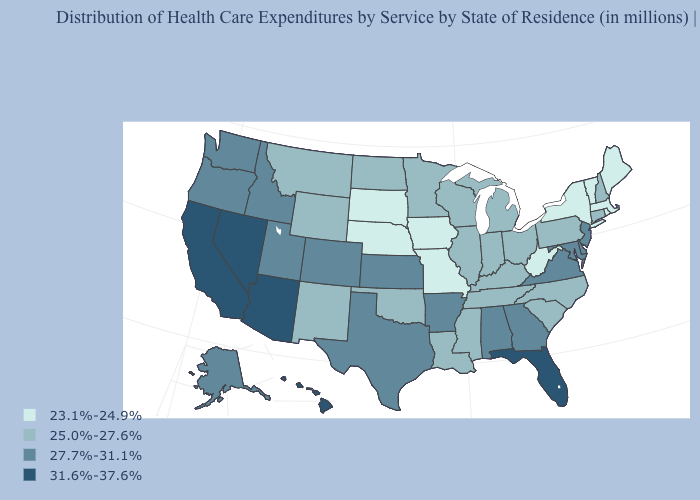Among the states that border Maine , which have the lowest value?
Concise answer only. New Hampshire. Does Nevada have the same value as California?
Answer briefly. Yes. Among the states that border Colorado , does Arizona have the highest value?
Write a very short answer. Yes. Is the legend a continuous bar?
Quick response, please. No. What is the lowest value in the USA?
Keep it brief. 23.1%-24.9%. Does Michigan have the highest value in the USA?
Answer briefly. No. What is the value of South Carolina?
Answer briefly. 25.0%-27.6%. Name the states that have a value in the range 31.6%-37.6%?
Write a very short answer. Arizona, California, Florida, Hawaii, Nevada. What is the value of Arkansas?
Quick response, please. 27.7%-31.1%. Does the map have missing data?
Answer briefly. No. Does Illinois have the same value as Alabama?
Keep it brief. No. Does Alaska have a higher value than Utah?
Give a very brief answer. No. Does Virginia have the lowest value in the South?
Short answer required. No. Among the states that border Kentucky , which have the highest value?
Keep it brief. Virginia. Name the states that have a value in the range 27.7%-31.1%?
Concise answer only. Alabama, Alaska, Arkansas, Colorado, Delaware, Georgia, Idaho, Kansas, Maryland, New Jersey, Oregon, Texas, Utah, Virginia, Washington. 